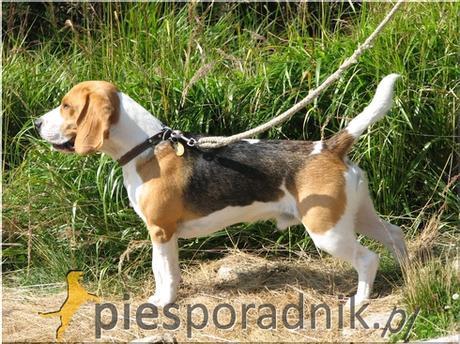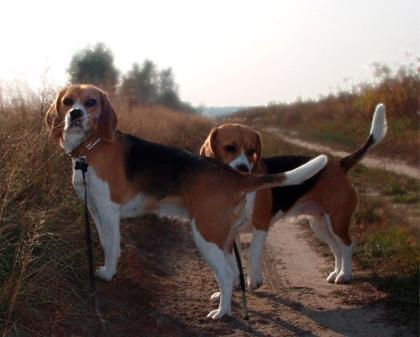The first image is the image on the left, the second image is the image on the right. Examine the images to the left and right. Is the description "At least one of the images shows three or more dogs." accurate? Answer yes or no. No. The first image is the image on the left, the second image is the image on the right. For the images displayed, is the sentence "In total, images contain no more than three beagles." factually correct? Answer yes or no. Yes. 